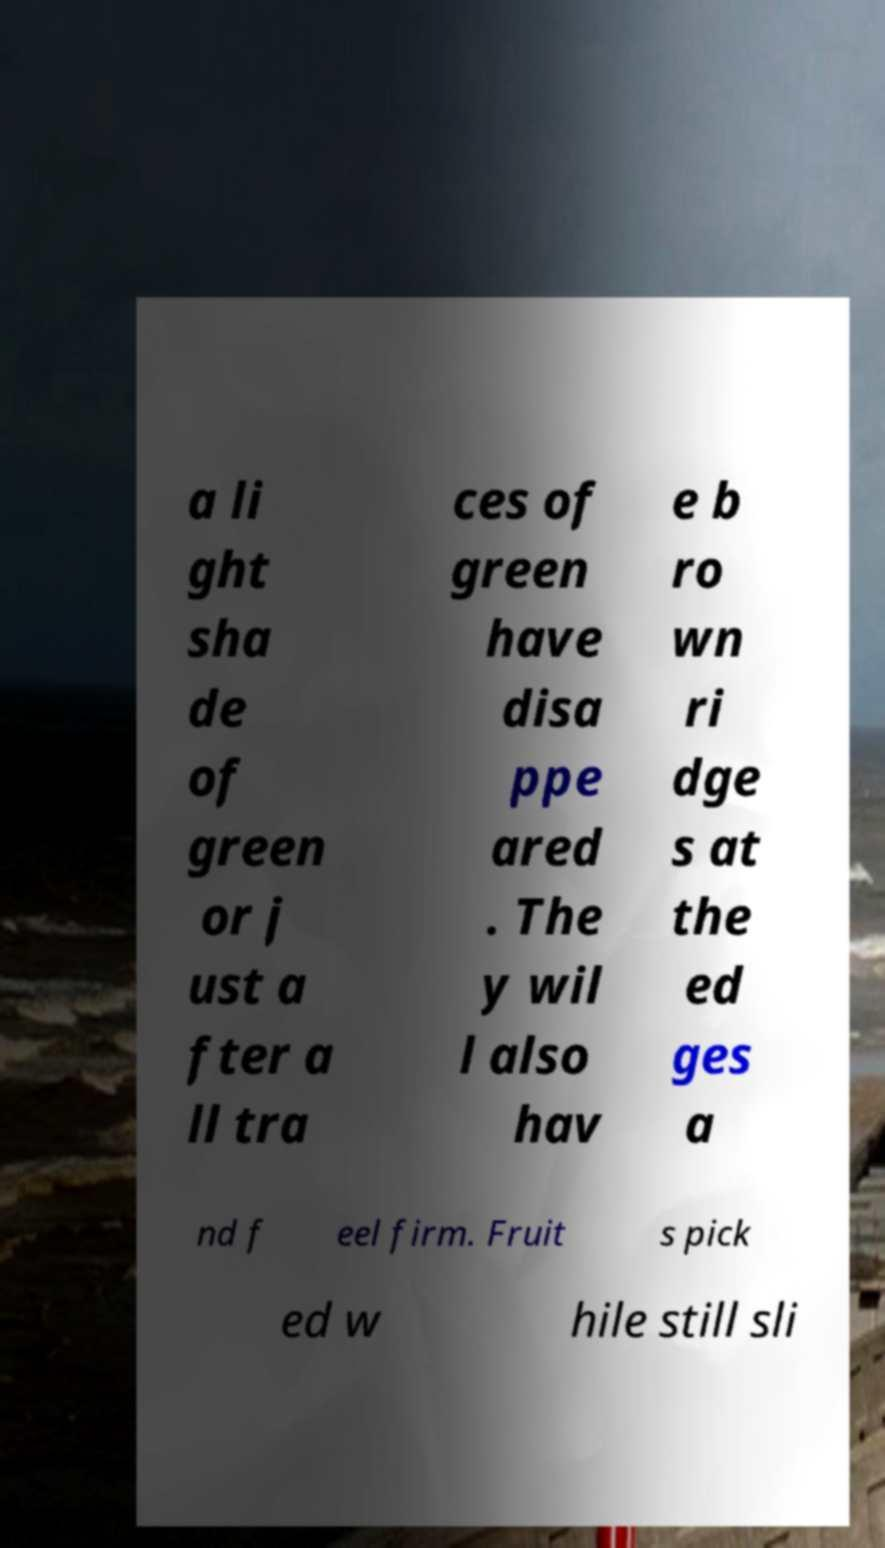Could you assist in decoding the text presented in this image and type it out clearly? a li ght sha de of green or j ust a fter a ll tra ces of green have disa ppe ared . The y wil l also hav e b ro wn ri dge s at the ed ges a nd f eel firm. Fruit s pick ed w hile still sli 